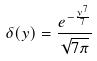Convert formula to latex. <formula><loc_0><loc_0><loc_500><loc_500>\delta ( y ) = \frac { e ^ { - \frac { y ^ { 7 } } { 7 } } } { \sqrt { 7 \pi } }</formula> 